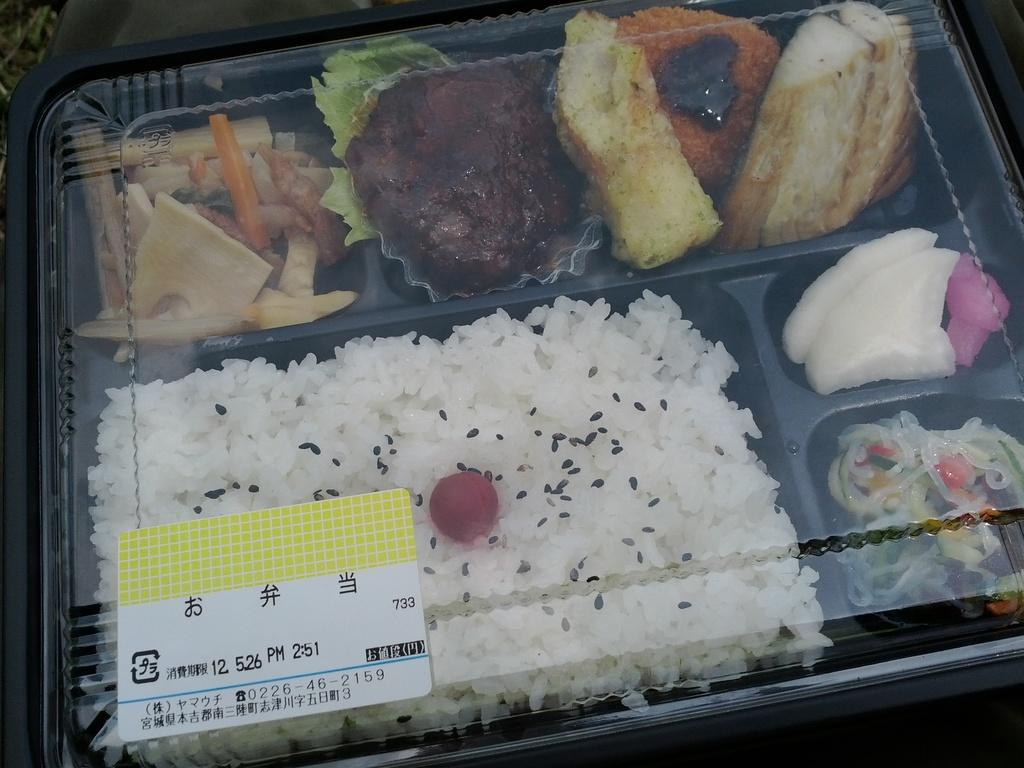What is present in the image? There is a box in the image. What is inside the box? The box contains food. Can you describe the contents of the box in more detail? There are different kinds of dishes in the box. What song is being played in the background of the image? There is no information about a song being played in the image. The image only shows a box containing food with different kinds of dishes. 